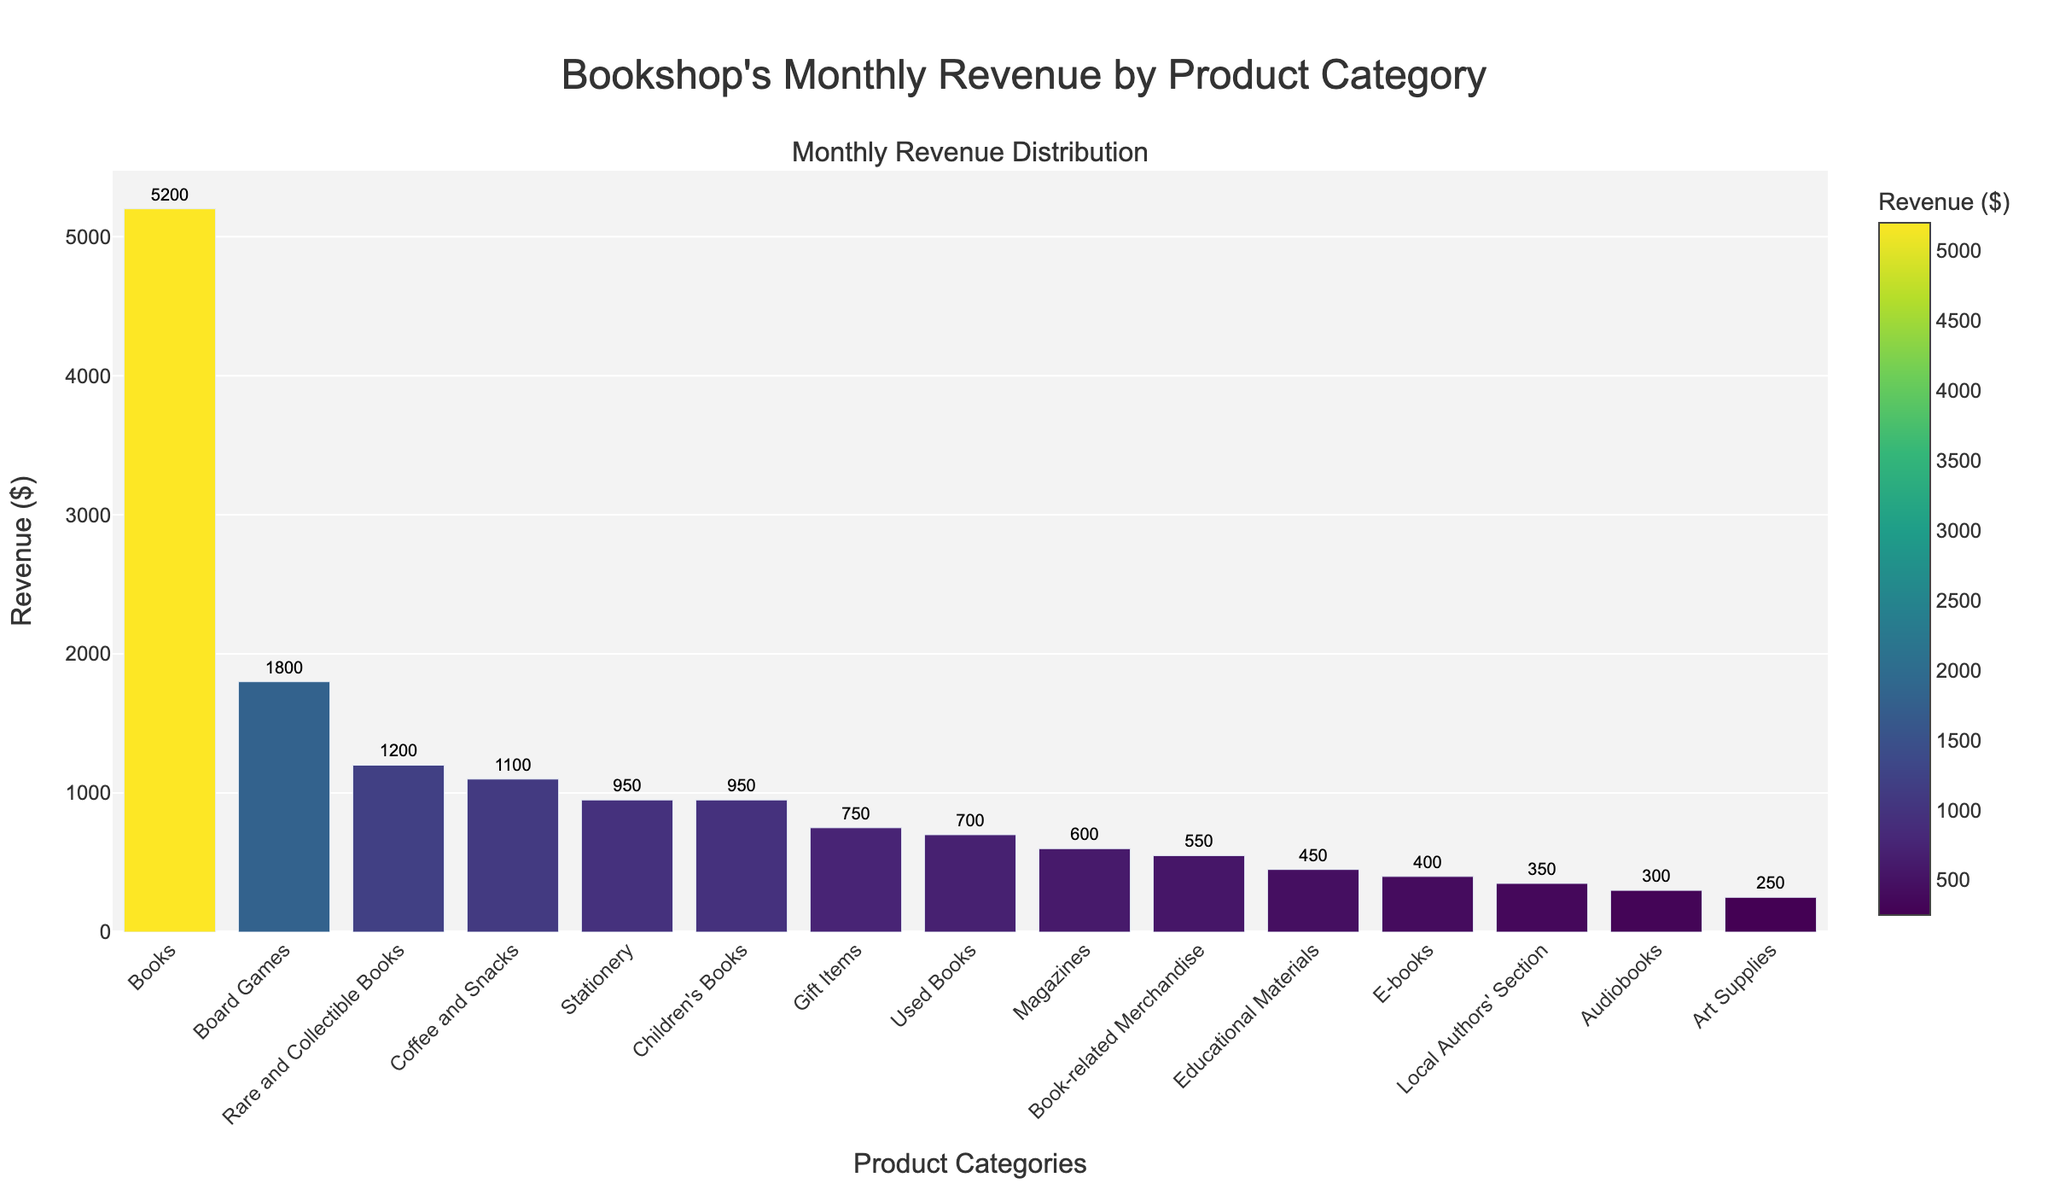What category has the highest revenue? By looking at the highest bar in the chart, we can identify the category with the highest revenue. The tallest bar corresponds to the 'Books' category.
Answer: Books Which category has the lowest revenue? To find the category with the lowest revenue, we look for the shortest bar in the chart. This corresponds to the 'Art Supplies' category.
Answer: Art Supplies What is the combined revenue of Board Games and Coffee and Snacks? To find this, we add the revenue of 'Board Games' (1800) and 'Coffee and Snacks' (1100). The combined revenue is 1800 + 1100 = 2900.
Answer: 2900 How much higher is the revenue for Books compared to E-books? We subtract the revenue of 'E-books' (400) from the revenue of 'Books' (5200). The difference is 5200 - 400 = 4800.
Answer: 4800 What is the average revenue of the top three categories? The top three categories by revenue are 'Books' (5200), 'Rare and Collectible Books' (1200), and 'Board Games' (1800). Their combined revenue is 5200 + 1200 + 1800 = 8200. The average revenue is 8200 / 3 = approximately 2733.33.
Answer: Approximately 2733.33 What percentage of total revenue is from Children's Books? First, calculate the total revenue by summing all categories. The total revenue is 16950. The revenue from 'Children's Books' is 950. The percentage is (950 / 16950) * 100 = approximately 5.6%.
Answer: Approximately 5.6% Are there any categories with equal revenue? By examining the height and value of the bars, we see that 'Stationery' and 'Children's Books' both have a revenue of 950.
Answer: Stationery and Children's Books Which categories have a revenue less than 500? Checking the bars with height representing revenue less than 500, we find 'E-books' (400), 'Audiobooks' (300), 'Local Authors' Section' (350), and 'Art Supplies' (250).
Answer: E-books, Audiobooks, Local Authors' Section, Art Supplies What is the combined revenue of all categories related to books (Books, E-books, Audiobooks, Rare and Collectible Books, Children's Books, Used Books)? Adding the revenues of these categories: 5200 (Books) + 400 (E-books) + 300 (Audiobooks) + 1200 (Rare and Collectible Books) + 950 (Children's Books) + 700 (Used Books) = 8750.
Answer: 8750 